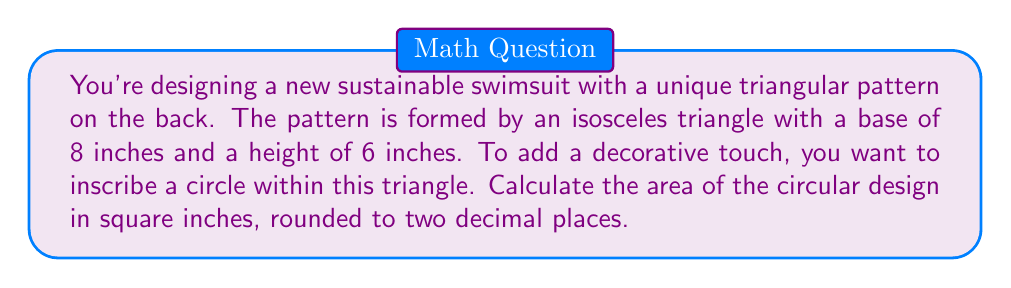Give your solution to this math problem. Let's approach this step-by-step:

1) First, we need to find the radius of the inscribed circle. In an isosceles triangle, the radius (r) of an inscribed circle is given by the formula:

   $$r = \frac{A}{s}$$

   where A is the area of the triangle and s is the semi-perimeter.

2) To find the area of the triangle:
   $$A = \frac{1}{2} \times base \times height = \frac{1}{2} \times 8 \times 6 = 24\text{ sq inches}$$

3) To find the semi-perimeter, we need the length of the sides. We can find this using the Pythagorean theorem:
   $$a^2 = (\frac{8}{2})^2 + 6^2 = 4^2 + 6^2 = 16 + 36 = 52$$
   $$a = \sqrt{52} = 7.21\text{ inches}$$

4) Now we can calculate the semi-perimeter:
   $$s = \frac{8 + 7.21 + 7.21}{2} = 11.21\text{ inches}$$

5) We can now find the radius:
   $$r = \frac{24}{11.21} = 2.14\text{ inches}$$

6) The area of the circular design is:
   $$A_{circle} = \pi r^2 = \pi \times 2.14^2 = 14.38\text{ sq inches}$$

7) Rounding to two decimal places: 14.38 sq inches
Answer: 14.38 sq inches 